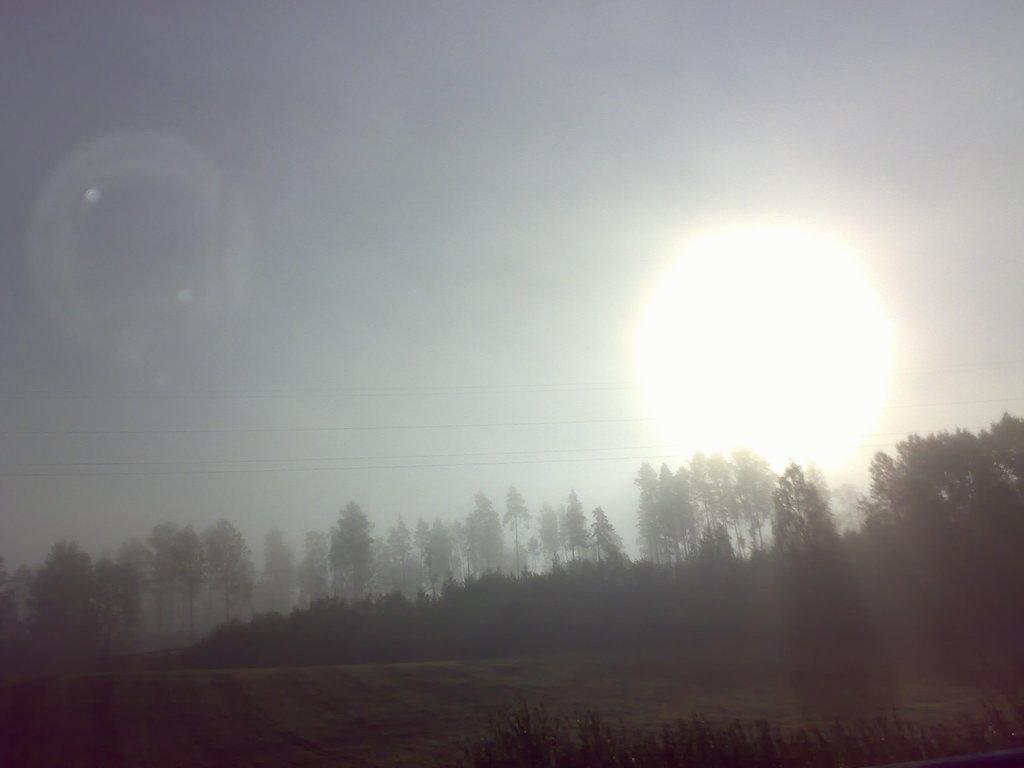What type of vegetation is present in the image? There are many trees in the image. What part of the natural environment is visible in the image? The ground is visible in the image. What can be seen in the background of the image? The sun and the sky are visible in the background of the image. What type of letters can be seen on the goose in the image? There is no goose or letters present in the image; it features trees, ground, sun, and sky. 